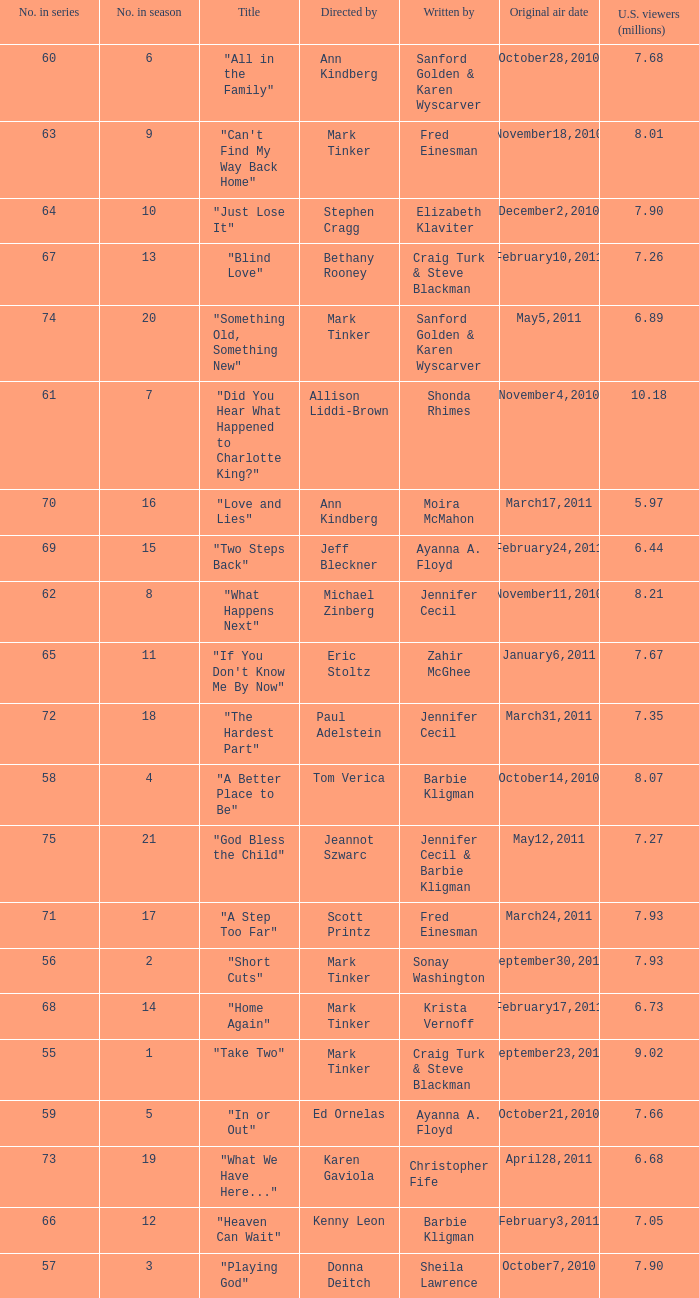What is the earliest numbered episode of the season? 1.0. Can you parse all the data within this table? {'header': ['No. in series', 'No. in season', 'Title', 'Directed by', 'Written by', 'Original air date', 'U.S. viewers (millions)'], 'rows': [['60', '6', '"All in the Family"', 'Ann Kindberg', 'Sanford Golden & Karen Wyscarver', 'October28,2010', '7.68'], ['63', '9', '"Can\'t Find My Way Back Home"', 'Mark Tinker', 'Fred Einesman', 'November18,2010', '8.01'], ['64', '10', '"Just Lose It"', 'Stephen Cragg', 'Elizabeth Klaviter', 'December2,2010', '7.90'], ['67', '13', '"Blind Love"', 'Bethany Rooney', 'Craig Turk & Steve Blackman', 'February10,2011', '7.26'], ['74', '20', '"Something Old, Something New"', 'Mark Tinker', 'Sanford Golden & Karen Wyscarver', 'May5,2011', '6.89'], ['61', '7', '"Did You Hear What Happened to Charlotte King?"', 'Allison Liddi-Brown', 'Shonda Rhimes', 'November4,2010', '10.18'], ['70', '16', '"Love and Lies"', 'Ann Kindberg', 'Moira McMahon', 'March17,2011', '5.97'], ['69', '15', '"Two Steps Back"', 'Jeff Bleckner', 'Ayanna A. Floyd', 'February24,2011', '6.44'], ['62', '8', '"What Happens Next"', 'Michael Zinberg', 'Jennifer Cecil', 'November11,2010', '8.21'], ['65', '11', '"If You Don\'t Know Me By Now"', 'Eric Stoltz', 'Zahir McGhee', 'January6,2011', '7.67'], ['72', '18', '"The Hardest Part"', 'Paul Adelstein', 'Jennifer Cecil', 'March31,2011', '7.35'], ['58', '4', '"A Better Place to Be"', 'Tom Verica', 'Barbie Kligman', 'October14,2010', '8.07'], ['75', '21', '"God Bless the Child"', 'Jeannot Szwarc', 'Jennifer Cecil & Barbie Kligman', 'May12,2011', '7.27'], ['71', '17', '"A Step Too Far"', 'Scott Printz', 'Fred Einesman', 'March24,2011', '7.93'], ['56', '2', '"Short Cuts"', 'Mark Tinker', 'Sonay Washington', 'September30,2010', '7.93'], ['68', '14', '"Home Again"', 'Mark Tinker', 'Krista Vernoff', 'February17,2011', '6.73'], ['55', '1', '"Take Two"', 'Mark Tinker', 'Craig Turk & Steve Blackman', 'September23,2010', '9.02'], ['59', '5', '"In or Out"', 'Ed Ornelas', 'Ayanna A. Floyd', 'October21,2010', '7.66'], ['73', '19', '"What We Have Here..."', 'Karen Gaviola', 'Christopher Fife', 'April28,2011', '6.68'], ['66', '12', '"Heaven Can Wait"', 'Kenny Leon', 'Barbie Kligman', 'February3,2011', '7.05'], ['57', '3', '"Playing God"', 'Donna Deitch', 'Sheila Lawrence', 'October7,2010', '7.90']]} 